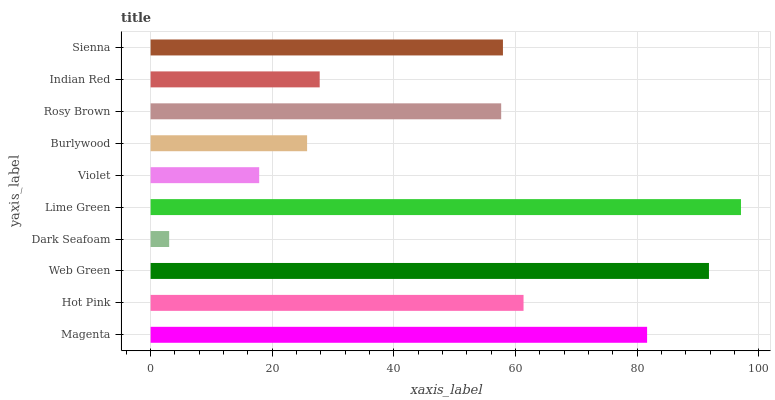Is Dark Seafoam the minimum?
Answer yes or no. Yes. Is Lime Green the maximum?
Answer yes or no. Yes. Is Hot Pink the minimum?
Answer yes or no. No. Is Hot Pink the maximum?
Answer yes or no. No. Is Magenta greater than Hot Pink?
Answer yes or no. Yes. Is Hot Pink less than Magenta?
Answer yes or no. Yes. Is Hot Pink greater than Magenta?
Answer yes or no. No. Is Magenta less than Hot Pink?
Answer yes or no. No. Is Sienna the high median?
Answer yes or no. Yes. Is Rosy Brown the low median?
Answer yes or no. Yes. Is Indian Red the high median?
Answer yes or no. No. Is Lime Green the low median?
Answer yes or no. No. 